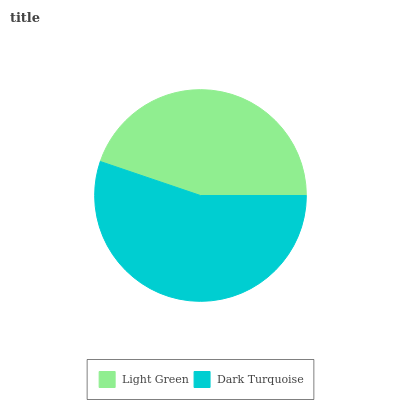Is Light Green the minimum?
Answer yes or no. Yes. Is Dark Turquoise the maximum?
Answer yes or no. Yes. Is Dark Turquoise the minimum?
Answer yes or no. No. Is Dark Turquoise greater than Light Green?
Answer yes or no. Yes. Is Light Green less than Dark Turquoise?
Answer yes or no. Yes. Is Light Green greater than Dark Turquoise?
Answer yes or no. No. Is Dark Turquoise less than Light Green?
Answer yes or no. No. Is Dark Turquoise the high median?
Answer yes or no. Yes. Is Light Green the low median?
Answer yes or no. Yes. Is Light Green the high median?
Answer yes or no. No. Is Dark Turquoise the low median?
Answer yes or no. No. 